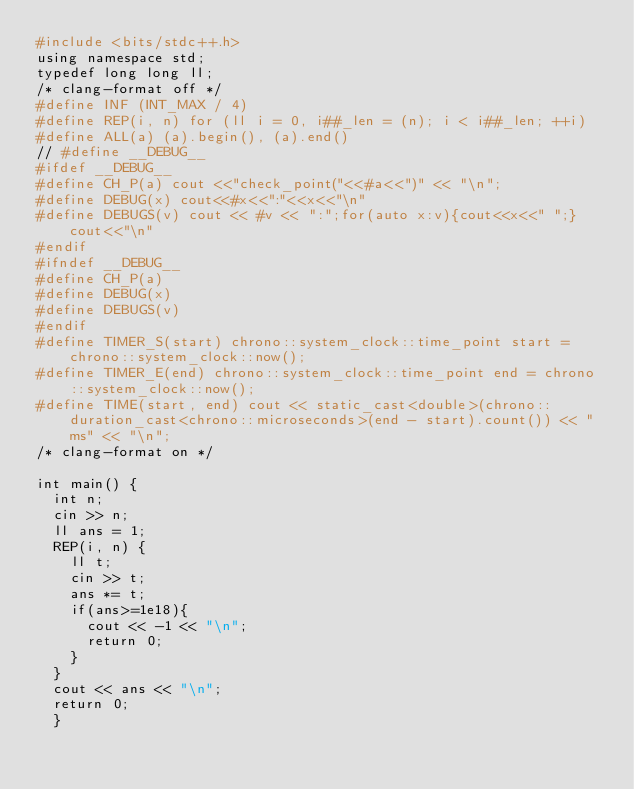Convert code to text. <code><loc_0><loc_0><loc_500><loc_500><_dc_>#include <bits/stdc++.h>
using namespace std;
typedef long long ll;
/* clang-format off */
#define INF (INT_MAX / 4)
#define REP(i, n) for (ll i = 0, i##_len = (n); i < i##_len; ++i)
#define ALL(a) (a).begin(), (a).end()
// #define __DEBUG__
#ifdef __DEBUG__
#define CH_P(a) cout <<"check_point("<<#a<<")" << "\n";
#define DEBUG(x) cout<<#x<<":"<<x<<"\n"
#define DEBUGS(v) cout << #v << ":";for(auto x:v){cout<<x<<" ";}cout<<"\n"
#endif
#ifndef __DEBUG__
#define CH_P(a) 
#define DEBUG(x) 
#define DEBUGS(v) 
#endif
#define TIMER_S(start) chrono::system_clock::time_point start = chrono::system_clock::now();
#define TIMER_E(end) chrono::system_clock::time_point end = chrono::system_clock::now();
#define TIME(start, end) cout << static_cast<double>(chrono::duration_cast<chrono::microseconds>(end - start).count()) << "ms" << "\n";
/* clang-format on */

int main() {
  int n;
  cin >> n;
  ll ans = 1;
  REP(i, n) { 
    ll t;
    cin >> t;
    ans *= t;
    if(ans>=1e18){
      cout << -1 << "\n";
      return 0;
    }
  }
  cout << ans << "\n";
  return 0;
  }
</code> 